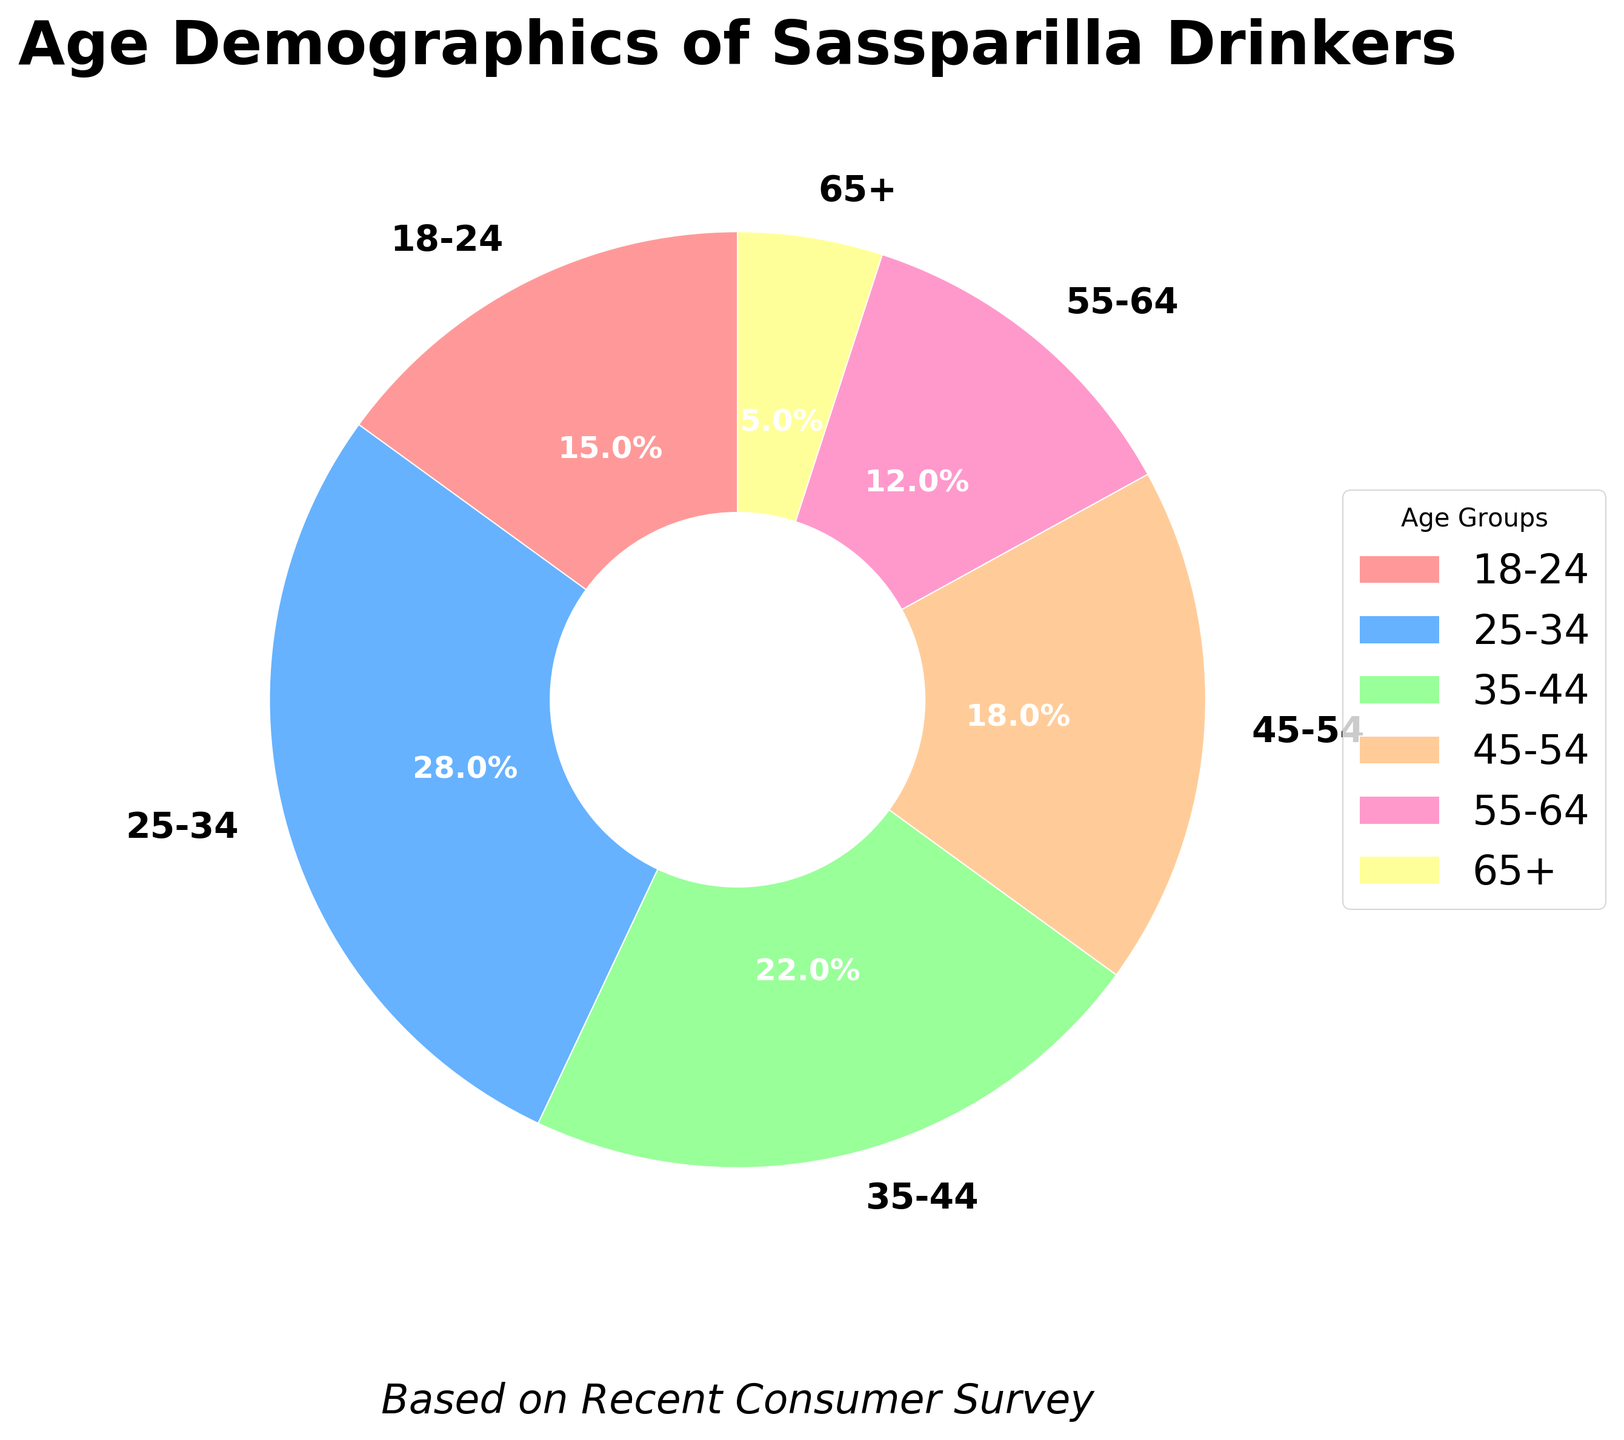What age group has the highest percentage of Sassparilla drinkers? The pie chart segments show the percentage of each age group. The 25-34 age group has the largest segment.
Answer: 25-34 What is the combined percentage of Sassparilla drinkers aged 45-54 and 55-64? From the chart, add the percentages for 45-54 and 55-64 age groups: 18% + 12% = 30%.
Answer: 30% Which age group has the lowest representation among Sassparilla drinkers? The 65+ age group has the smallest segment.
Answer: 65+ By how much does the percentage of drinkers aged 25-34 exceed that of drinkers aged 18-24? Subtract the percentage of 18-24 age group from 25-34 age group: 28% - 15% = 13%.
Answer: 13% What is the average percentage of Sassparilla drinkers in the age groups 35-44, 45-54, and 55-64? Add the percentages of the three groups and divide by 3: (22% + 18% + 12%) / 3 = 52% / 3 ≈ 17.3%.
Answer: 17.3% How much more popular is Sassparilla among the 35-44 age group compared to the 55-64 age group? Subtract the percentage of the 55-64 age group from the 35-44 age group: 22% - 12% = 10%.
Answer: 10% Which age groups have higher than 20% representation in Sassparilla drinking? The age groups 18-24 (15%), 25-34 (28%), 35-44 (22%), 45-54 (18%), 55-64 (12%), and 65+ (5%). Among them, only 25-34 and 35-44 are greater than 20%.
Answer: 25-34 and 35-44 What percentage of Sassparilla drinkers are aged below 35? Combine the percentages for 18-24 and 25-34 age groups: 15% + 28% =43%.
Answer: 43% Is the percentage of Sassparilla drinkers in the age group 35-44 greater than the percentage in the combined age group 55-64 and 65+? The percentage for 35-44 is 22%. The combined percentage for 55-64 and 65+ is 12% + 5% = 17%. Since 22% > 17%, the answer is yes.
Answer: Yes 